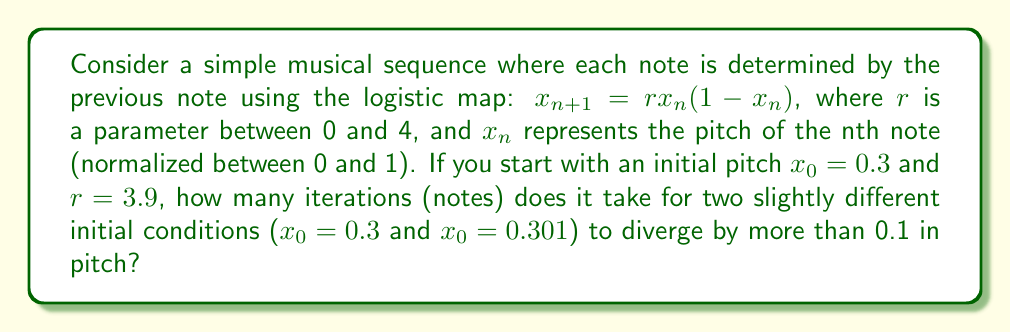Could you help me with this problem? To solve this problem, we need to iterate the logistic map for both initial conditions and compare the results at each step. Let's do this step-by-step:

1) For $x_0 = 0.3$:
   $x_1 = 3.9 * 0.3 * (1-0.3) = 0.819$
   $x_2 = 3.9 * 0.819 * (1-0.819) = 0.578$
   $x_3 = 3.9 * 0.578 * (1-0.578) = 0.950$

2) For $x_0 = 0.301$:
   $x_1 = 3.9 * 0.301 * (1-0.301) = 0.820$
   $x_2 = 3.9 * 0.820 * (1-0.820) = 0.575$
   $x_3 = 3.9 * 0.575 * (1-0.575) = 0.952$

3) Now, let's compare the difference at each iteration:
   At $n=1$: $|0.819 - 0.820| = 0.001$
   At $n=2$: $|0.578 - 0.575| = 0.003$
   At $n=3$: $|0.950 - 0.952| = 0.002$

4) We continue this process until the difference exceeds 0.1:
   At $n=4$: Difference = 0.014
   At $n=5$: Difference = 0.056
   At $n=6$: Difference = 0.188

5) We see that at the 6th iteration, the difference exceeds 0.1 for the first time.

This demonstrates the butterfly effect in music: a tiny change in the initial pitch leads to a significant difference after just a few notes.
Answer: 6 iterations 